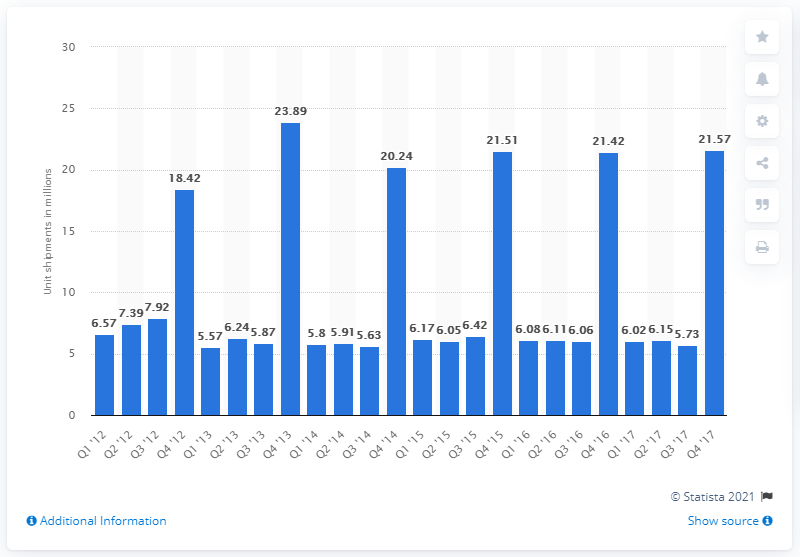Specify some key components in this picture. In the fourth quarter of 2017, it was projected that 21.57 digital televisions would be shipped in the United States. In recent years, the number of individual televisions sold annually has been approximately 21.57. 